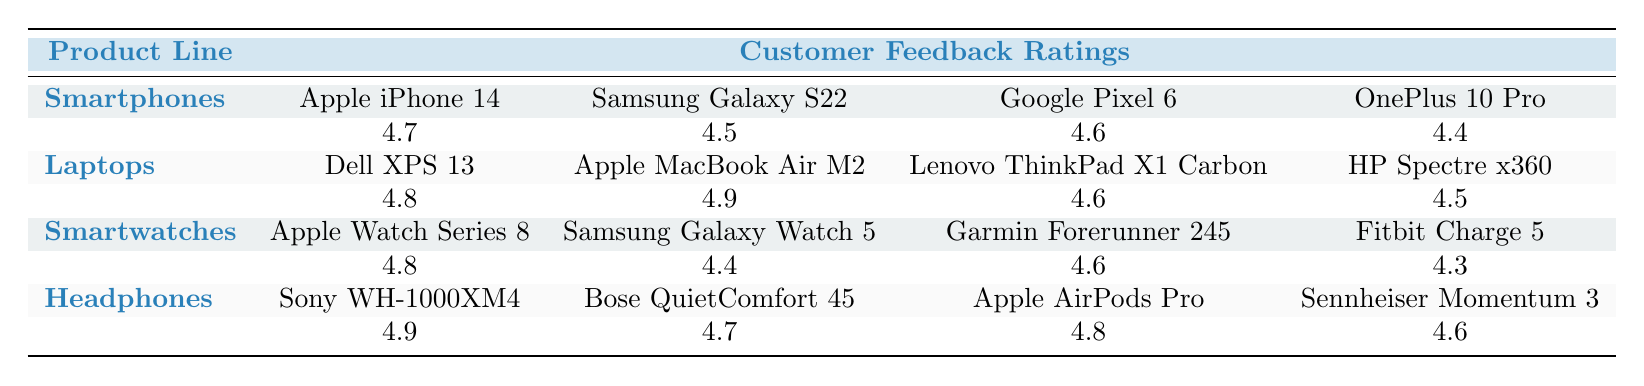What is the highest customer feedback rating among smartphones? The smartphone ratings listed are: Apple iPhone 14 (4.7), Samsung Galaxy S22 (4.5), Google Pixel 6 (4.6), and OnePlus 10 Pro (4.4). The highest value among these is 4.7, which corresponds to the Apple iPhone 14.
Answer: 4.7 Which laptop received the lowest customer feedback rating? The ratings for laptops are: Dell XPS 13 (4.8), Apple MacBook Air M2 (4.9), Lenovo ThinkPad X1 Carbon (4.6), and HP Spectre x360 (4.5). The lowest value here is 4.5 for the HP Spectre x360.
Answer: HP Spectre x360 Is the average customer feedback rating for smartwatches greater than 4.5? The ratings for smartwatches are Apple Watch Series 8 (4.8), Samsung Galaxy Watch 5 (4.4), Garmin Forerunner 245 (4.6), and Fitbit Charge 5 (4.3). The average is (4.8 + 4.4 + 4.6 + 4.3) / 4 = 4.525, which is indeed greater than 4.5.
Answer: Yes What is the difference between the highest-rated headphone and the highest-rated laptop? The highest-rated headphone is Sony WH-1000XM4 (4.9), while the highest-rated laptop is Apple MacBook Air M2 (4.9) as well. Therefore, the difference is 4.9 - 4.9 = 0.
Answer: 0 Does the Samsung Galaxy S22 have a higher rating than the Lenovo ThinkPad X1 Carbon? The rating for Samsung Galaxy S22 is 4.5 and for Lenovo ThinkPad X1 Carbon it is 4.6. Since 4.5 is less than 4.6, the statement is false.
Answer: No Which product line has the lowest average customer feedback rating? The average ratings for each product line are: Smartphones: (4.7 + 4.5 + 4.6 + 4.4) / 4 = 4.5, Laptops: (4.8 + 4.9 + 4.6 + 4.5) / 4 = 4.675, Smartwatches: (4.8 + 4.4 + 4.6 + 4.3) / 4 = 4.525, Headphones: (4.9 + 4.7 + 4.8 + 4.6) / 4 = 4.75. The lowest average is 4.5 for Smartphones.
Answer: Smartphones Which smartwatch has the lowest rating among the four listed? The smartwatches and their ratings are: Apple Watch Series 8 (4.8), Samsung Galaxy Watch 5 (4.4), Garmin Forerunner 245 (4.6), and Fitbit Charge 5 (4.3). Out of these, Fitbit Charge 5 has the lowest rating at 4.3.
Answer: Fitbit Charge 5 Are the average ratings for headphones and smartphones the same? The average rating for headphones is (4.9 + 4.7 + 4.8 + 4.6) / 4 = 4.75. The average for smartphones is (4.7 + 4.5 + 4.6 + 4.4) / 4 = 4.5. Since 4.75 is not equal to 4.5, they are not the same.
Answer: No 